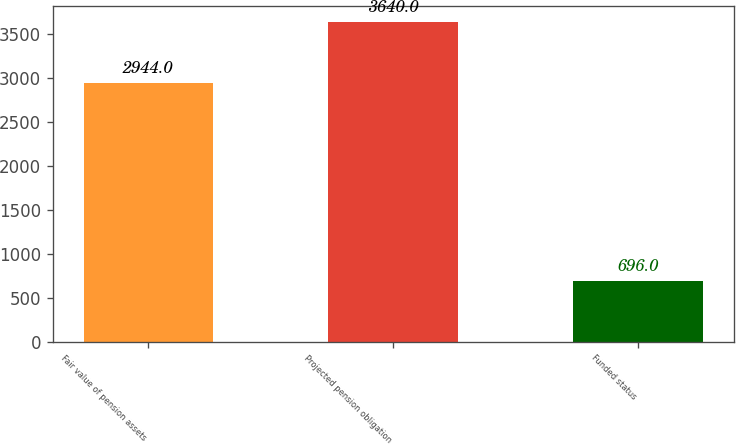<chart> <loc_0><loc_0><loc_500><loc_500><bar_chart><fcel>Fair value of pension assets<fcel>Projected pension obligation<fcel>Funded status<nl><fcel>2944<fcel>3640<fcel>696<nl></chart> 